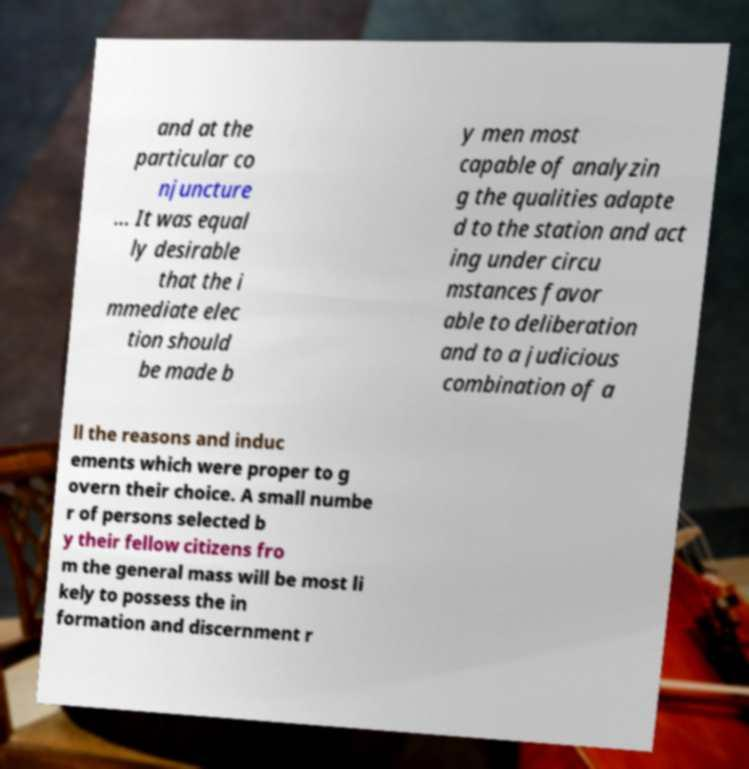Please read and relay the text visible in this image. What does it say? and at the particular co njuncture ... It was equal ly desirable that the i mmediate elec tion should be made b y men most capable of analyzin g the qualities adapte d to the station and act ing under circu mstances favor able to deliberation and to a judicious combination of a ll the reasons and induc ements which were proper to g overn their choice. A small numbe r of persons selected b y their fellow citizens fro m the general mass will be most li kely to possess the in formation and discernment r 